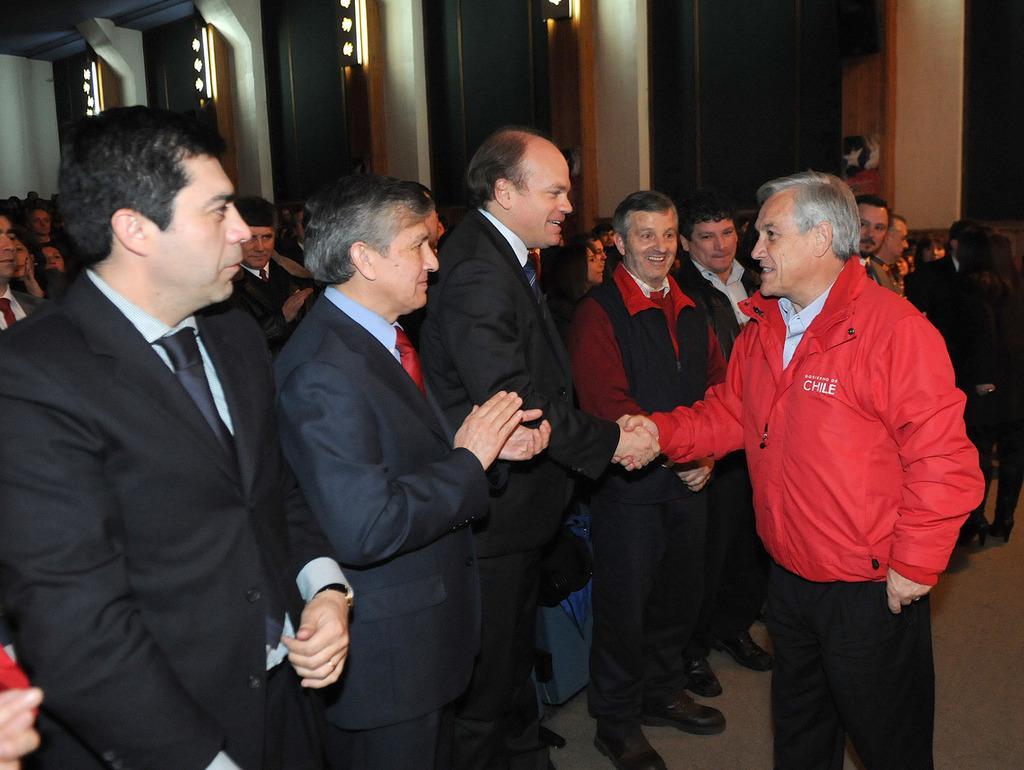In one or two sentences, can you explain what this image depicts? This is the picture of a place where we have a person who is shaking the hand with the other person who is in black suit and around there are some other people. 